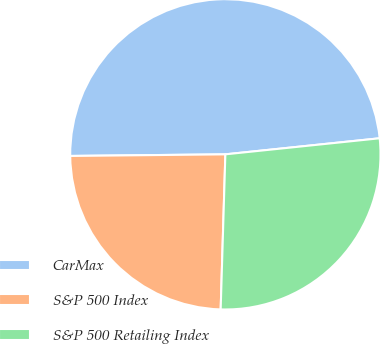Convert chart. <chart><loc_0><loc_0><loc_500><loc_500><pie_chart><fcel>CarMax<fcel>S&P 500 Index<fcel>S&P 500 Retailing Index<nl><fcel>48.51%<fcel>24.35%<fcel>27.13%<nl></chart> 